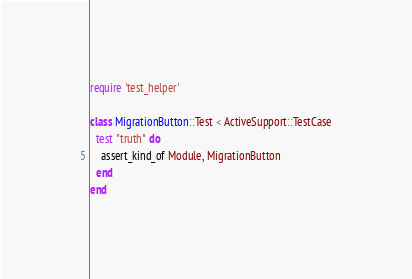<code> <loc_0><loc_0><loc_500><loc_500><_Ruby_>require 'test_helper'

class MigrationButton::Test < ActiveSupport::TestCase
  test "truth" do
    assert_kind_of Module, MigrationButton
  end
end
</code> 